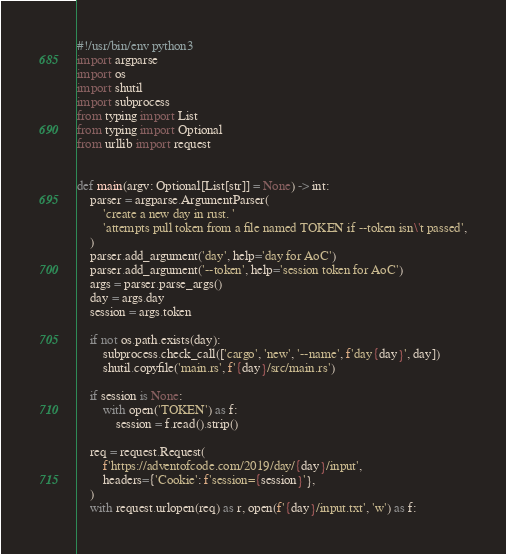Convert code to text. <code><loc_0><loc_0><loc_500><loc_500><_Python_>#!/usr/bin/env python3
import argparse
import os
import shutil
import subprocess
from typing import List
from typing import Optional
from urllib import request


def main(argv: Optional[List[str]] = None) -> int:
    parser = argparse.ArgumentParser(
        'create a new day in rust. '
        'attempts pull token from a file named TOKEN if --token isn\'t passed',
    )
    parser.add_argument('day', help='day for AoC')
    parser.add_argument('--token', help='session token for AoC')
    args = parser.parse_args()
    day = args.day
    session = args.token

    if not os.path.exists(day):
        subprocess.check_call(['cargo', 'new', '--name', f'day{day}', day])
        shutil.copyfile('main.rs', f'{day}/src/main.rs')

    if session is None:
        with open('TOKEN') as f:
            session = f.read().strip()

    req = request.Request(
        f'https://adventofcode.com/2019/day/{day}/input',
        headers={'Cookie': f'session={session}'},
    )
    with request.urlopen(req) as r, open(f'{day}/input.txt', 'w') as f:</code> 